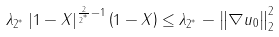<formula> <loc_0><loc_0><loc_500><loc_500>\lambda _ { 2 ^ { ^ { * } } } \left | 1 - X \right | ^ { \frac { 2 } { 2 ^ { ^ { * } } } - 1 } \left ( 1 - X \right ) \leq \lambda _ { 2 ^ { ^ { * } } } - \left \| \nabla u _ { 0 } \right \| _ { 2 } ^ { 2 }</formula> 